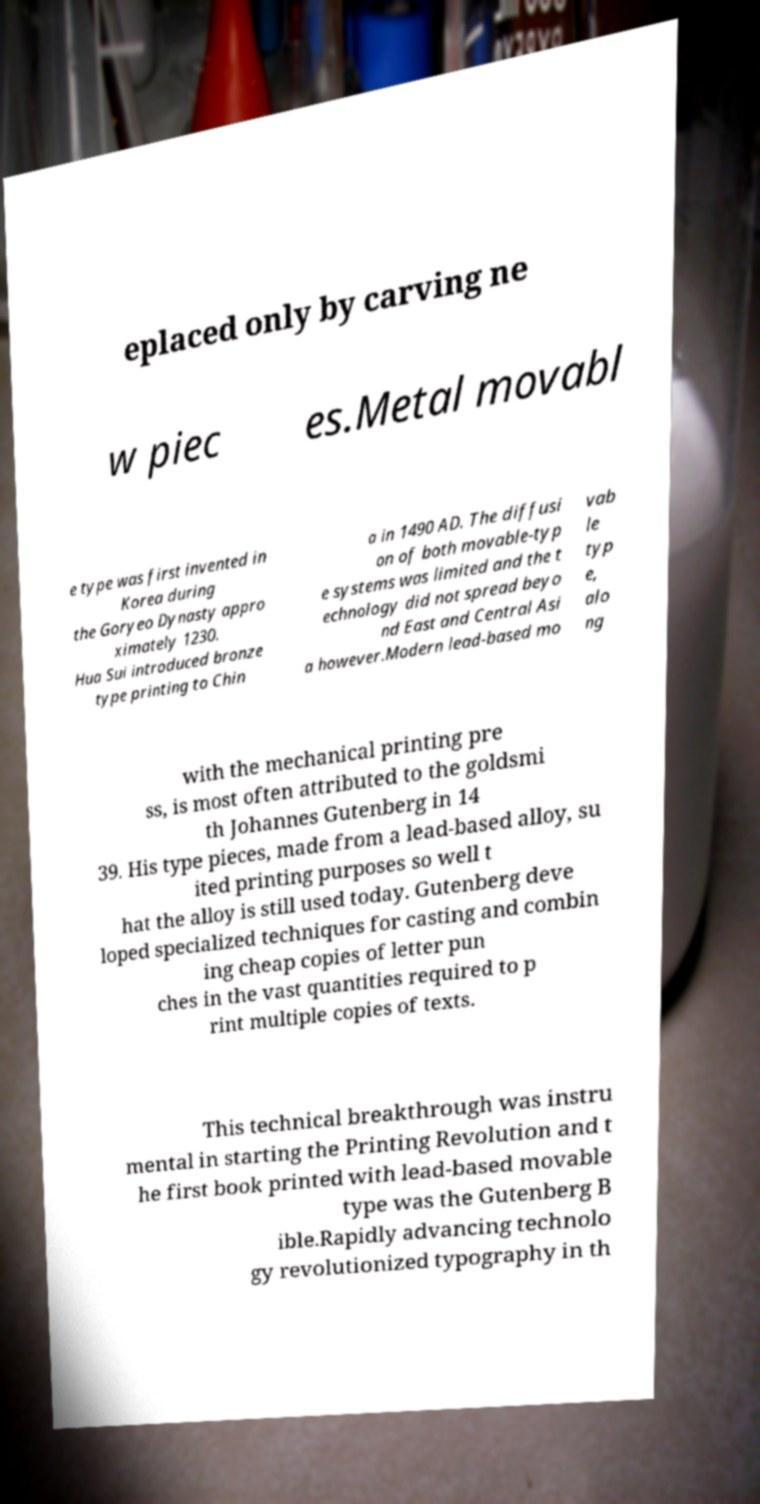Can you accurately transcribe the text from the provided image for me? eplaced only by carving ne w piec es.Metal movabl e type was first invented in Korea during the Goryeo Dynasty appro ximately 1230. Hua Sui introduced bronze type printing to Chin a in 1490 AD. The diffusi on of both movable-typ e systems was limited and the t echnology did not spread beyo nd East and Central Asi a however.Modern lead-based mo vab le typ e, alo ng with the mechanical printing pre ss, is most often attributed to the goldsmi th Johannes Gutenberg in 14 39. His type pieces, made from a lead-based alloy, su ited printing purposes so well t hat the alloy is still used today. Gutenberg deve loped specialized techniques for casting and combin ing cheap copies of letter pun ches in the vast quantities required to p rint multiple copies of texts. This technical breakthrough was instru mental in starting the Printing Revolution and t he first book printed with lead-based movable type was the Gutenberg B ible.Rapidly advancing technolo gy revolutionized typography in th 